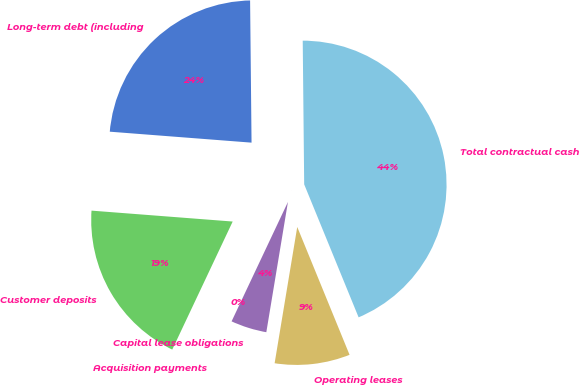Convert chart to OTSL. <chart><loc_0><loc_0><loc_500><loc_500><pie_chart><fcel>Long-term debt (including<fcel>Customer deposits<fcel>Acquisition payments<fcel>Capital lease obligations<fcel>Operating leases<fcel>Total contractual cash<nl><fcel>23.61%<fcel>19.21%<fcel>0.0%<fcel>4.4%<fcel>8.8%<fcel>43.98%<nl></chart> 